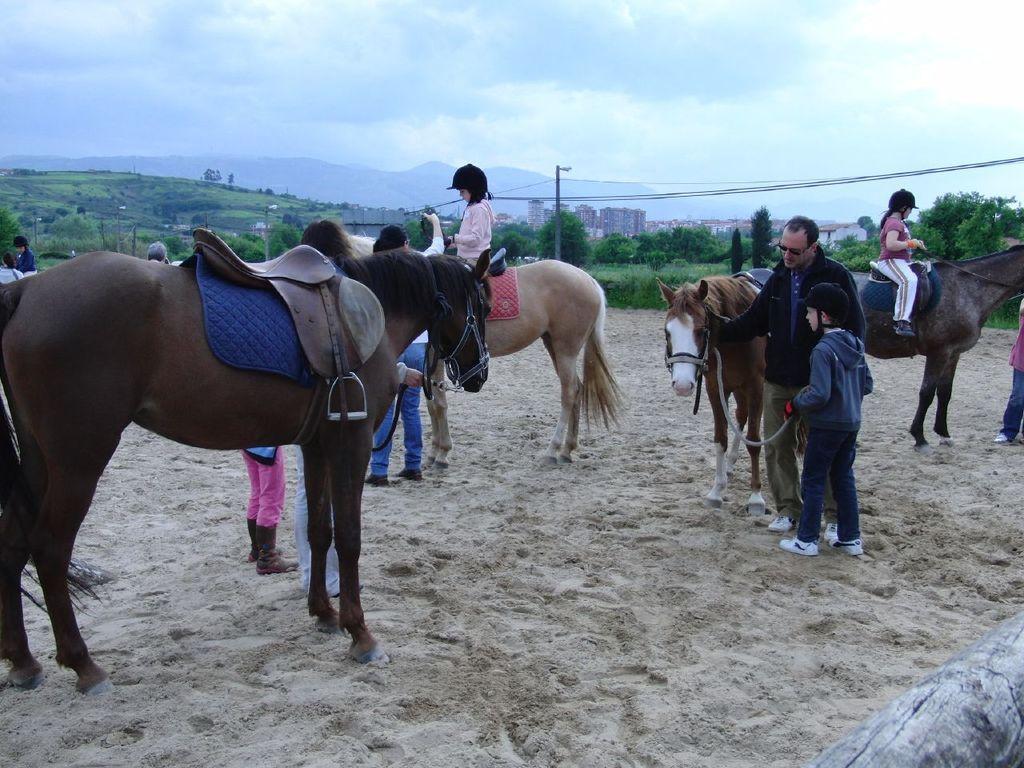Can you describe this image briefly? In this image there are horses on a sandy land, few people are sitting on horses and few are standing, in the background there are trees, poles, mountains and the sky. 